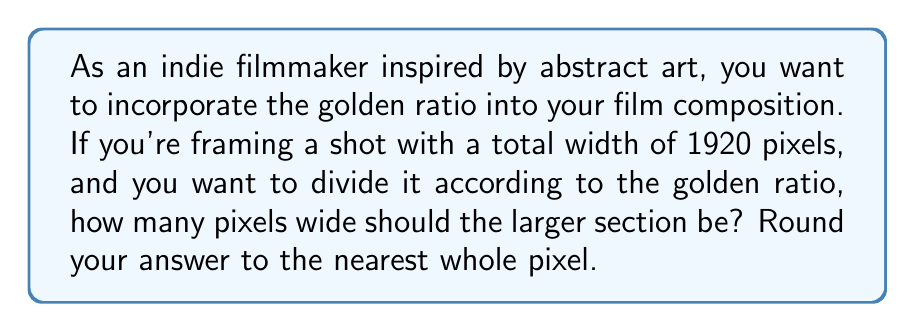Help me with this question. To solve this problem, we'll follow these steps:

1) The golden ratio, denoted by φ (phi), is approximately equal to 1.618033988749895.

2) In a composition divided by the golden ratio, the ratio of the larger part to the smaller part is equal to the ratio of the whole to the larger part. We can express this mathematically as:

   $$\frac{a}{b} = \frac{a+b}{a} = φ$$

   Where $a$ is the larger part and $b$ is the smaller part.

3) Given that the total width is 1920 pixels, we can say:

   $$a + b = 1920$$

4) We want to find $a$. Using the golden ratio equation:

   $$\frac{1920}{a} = φ$$

5) Solving for $a$:

   $$a = \frac{1920}{φ}$$

6) Substituting the value of φ:

   $$a = \frac{1920}{1.618033988749895}$$

7) Calculating:

   $$a ≈ 1186.2745098039216$$

8) Rounding to the nearest whole pixel:

   $$a ≈ 1186 \text{ pixels}$$
Answer: 1186 pixels 